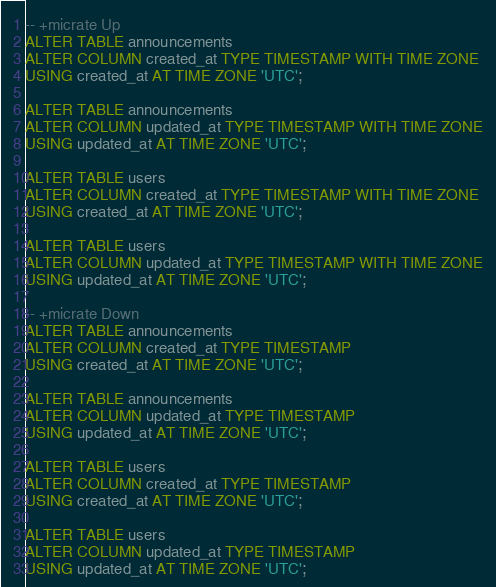Convert code to text. <code><loc_0><loc_0><loc_500><loc_500><_SQL_>-- +micrate Up
ALTER TABLE announcements
ALTER COLUMN created_at TYPE TIMESTAMP WITH TIME ZONE
USING created_at AT TIME ZONE 'UTC';

ALTER TABLE announcements
ALTER COLUMN updated_at TYPE TIMESTAMP WITH TIME ZONE
USING updated_at AT TIME ZONE 'UTC';

ALTER TABLE users
ALTER COLUMN created_at TYPE TIMESTAMP WITH TIME ZONE
USING created_at AT TIME ZONE 'UTC';

ALTER TABLE users
ALTER COLUMN updated_at TYPE TIMESTAMP WITH TIME ZONE
USING updated_at AT TIME ZONE 'UTC';

-- +micrate Down
ALTER TABLE announcements
ALTER COLUMN created_at TYPE TIMESTAMP
USING created_at AT TIME ZONE 'UTC';

ALTER TABLE announcements
ALTER COLUMN updated_at TYPE TIMESTAMP
USING updated_at AT TIME ZONE 'UTC';

ALTER TABLE users
ALTER COLUMN created_at TYPE TIMESTAMP
USING created_at AT TIME ZONE 'UTC';

ALTER TABLE users
ALTER COLUMN updated_at TYPE TIMESTAMP
USING updated_at AT TIME ZONE 'UTC';
</code> 